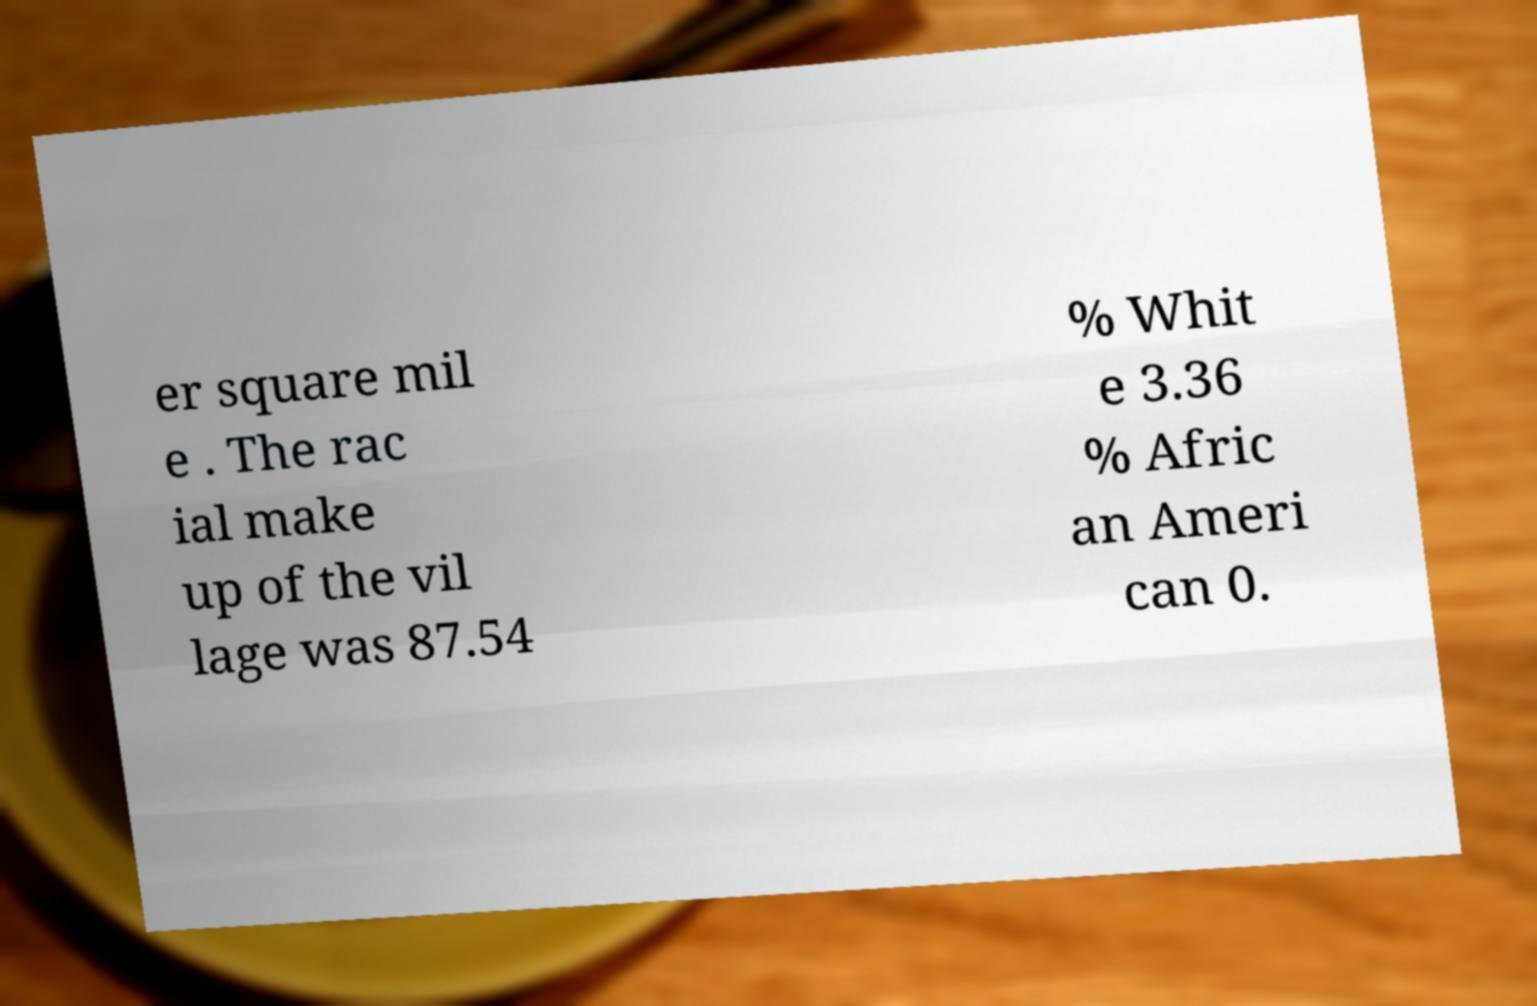Could you extract and type out the text from this image? er square mil e . The rac ial make up of the vil lage was 87.54 % Whit e 3.36 % Afric an Ameri can 0. 